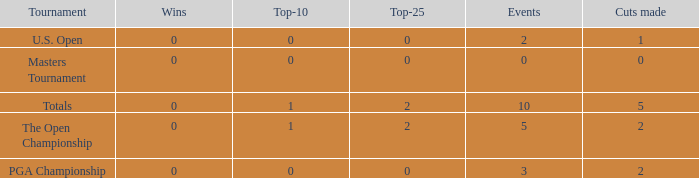What is the sum of top-10s for events with more than 0 wins? None. 